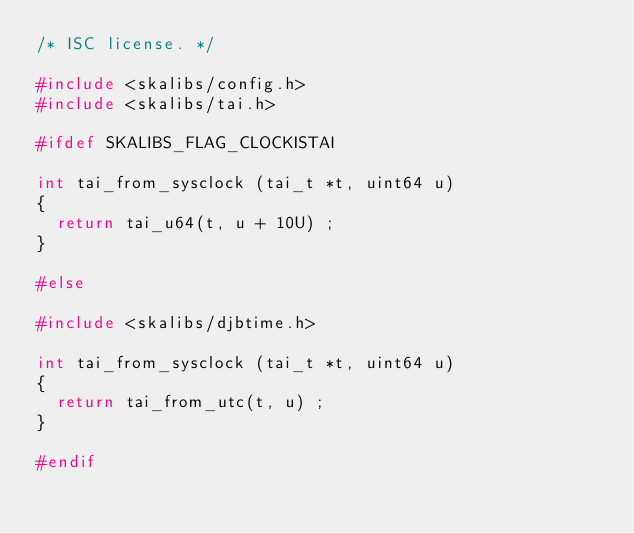<code> <loc_0><loc_0><loc_500><loc_500><_C_>/* ISC license. */

#include <skalibs/config.h>
#include <skalibs/tai.h>

#ifdef SKALIBS_FLAG_CLOCKISTAI

int tai_from_sysclock (tai_t *t, uint64 u)
{
  return tai_u64(t, u + 10U) ;
}

#else

#include <skalibs/djbtime.h>

int tai_from_sysclock (tai_t *t, uint64 u)
{
  return tai_from_utc(t, u) ;
}

#endif
</code> 